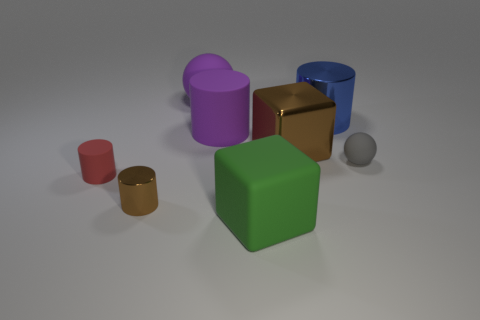What is the shape of the big metallic thing on the right side of the brown metal thing behind the tiny matte object right of the big brown shiny thing?
Offer a terse response. Cylinder. The big thing that is behind the purple matte cylinder and on the left side of the large shiny cylinder is made of what material?
Your answer should be compact. Rubber. What is the color of the shiny cylinder that is to the left of the large metallic object right of the brown object that is to the right of the small brown object?
Offer a terse response. Brown. What number of green objects are either large matte blocks or small balls?
Your response must be concise. 1. What number of other objects are there of the same size as the blue thing?
Your answer should be compact. 4. How many tiny purple blocks are there?
Keep it short and to the point. 0. Is there anything else that has the same shape as the gray thing?
Give a very brief answer. Yes. Is the material of the ball behind the blue shiny cylinder the same as the small cylinder that is in front of the tiny red thing?
Your answer should be very brief. No. What is the brown cylinder made of?
Offer a very short reply. Metal. How many blue objects have the same material as the brown cylinder?
Ensure brevity in your answer.  1. 